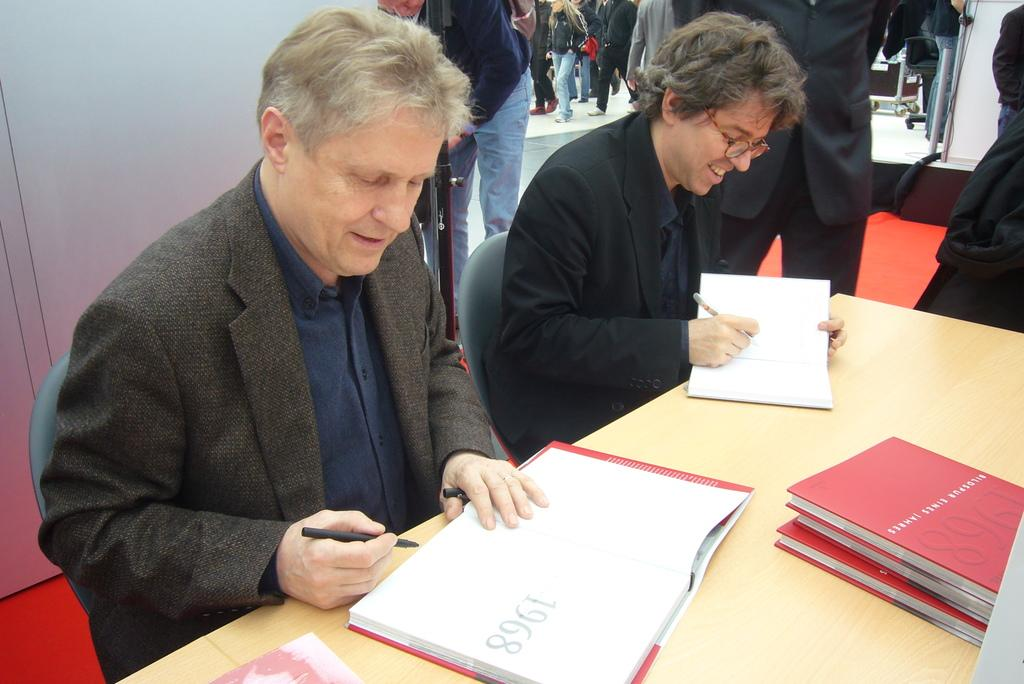How many men are in the image? There are two men in the image. What are the men doing in the image? The men are sitting on chairs and holding books and pens. What can be found on the table in the image? There are books on the table. What is visible in the background of the image? There are people, rods, a wall, and chairs in the background of the image. What type of root can be seen growing from the chair in the image? There is no root growing from the chair in the image. What invention is the men discussing in the image? The image does not provide any information about what the men might be discussing. 